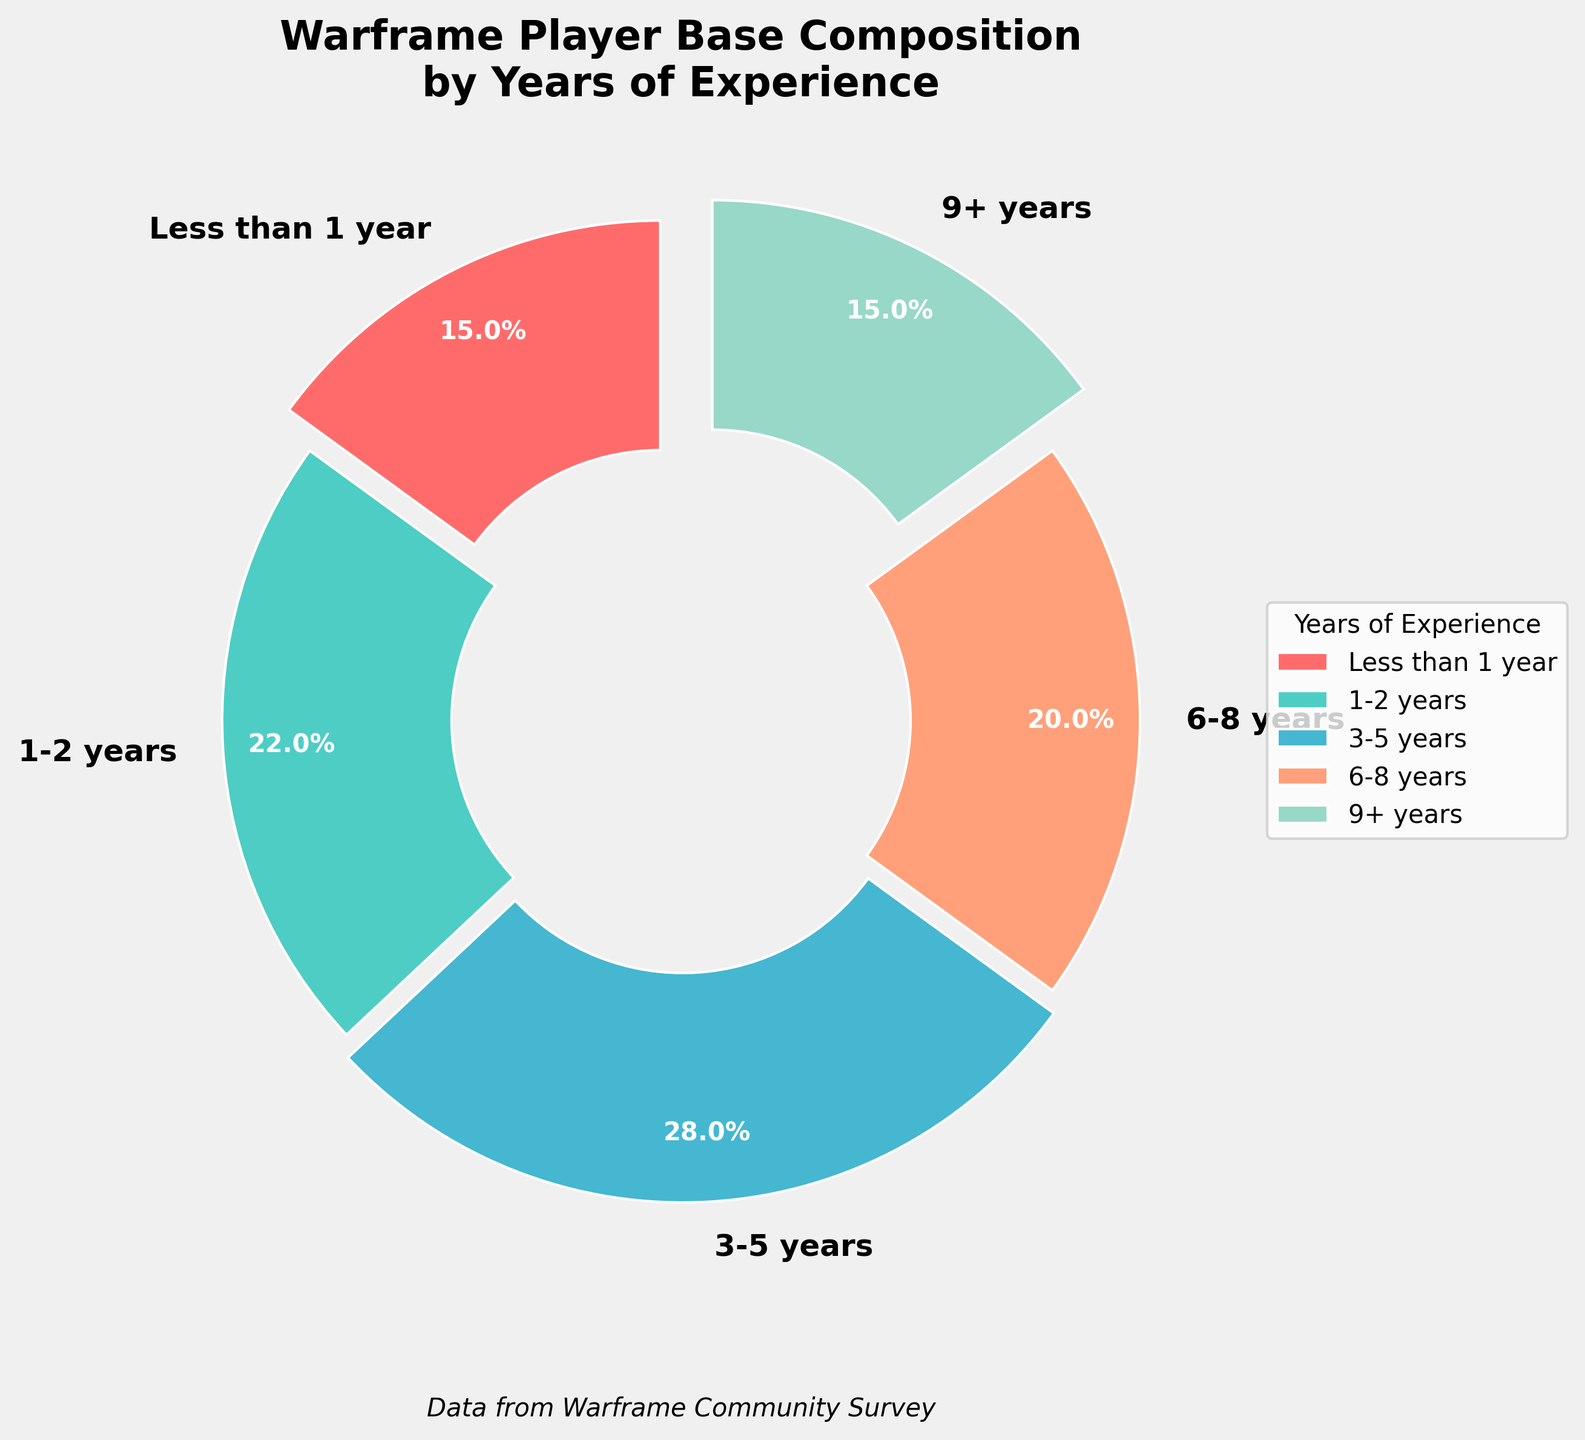What's the percentage of players with 1-2 years of experience? From the chart, the label for "1-2 years" of experience shows a percentage directly as part of the pie slice.
Answer: 22% Which group has the smallest percentage of players? By observing the chart, the slices and their corresponding percentages can be compared visually and numerically. The groups "Less than 1 year" and "9+ years" both show the smallest percentage of 15%.
Answer: Less than 1 year and 9+ years How many years of experience categories have more than 20% of the player base? From the chart, the slices with their percentages reveal that the "1-2 years" (22%), "3-5 years" (28%), and "6-8 years" (20%) categories have more than 20%.
Answer: 3 categories What is the combined percentage of players with either less than 1 year or more than 9 years of experience? Adding the percentages for "Less than 1 year" (15%) and "9+ years" (15%) gives us the combined percentage.
Answer: 30% Which group has the highest percentage of players? By visually inspecting the chart, it is evident that the slice with the "3-5 years" category is the largest, and its percentage is 28%.
Answer: 3-5 years Compare the player base percentages of those with 6-8 years of experience to those with 1-2 years of experience. The percentage for the "6-8 years" category is 20%, while it is 22% for the "1-2 years" category. Hence, the "1-2 years" category has a slightly higher percentage.
Answer: 1-2 years > 6-8 years What percentage of the player base has less than 3 years of experience in total? Adding the percentages for "Less than 1 year" (15%) and "1-2 years" (22%) gives the total percentage of players with less than 3 years of experience.
Answer: 37% Which color represents the "3-5 years" experience group in the pie chart? By associating the labels with their respective slices' colors visually, the "3-5 years" group is shown in light blue.
Answer: Light blue 